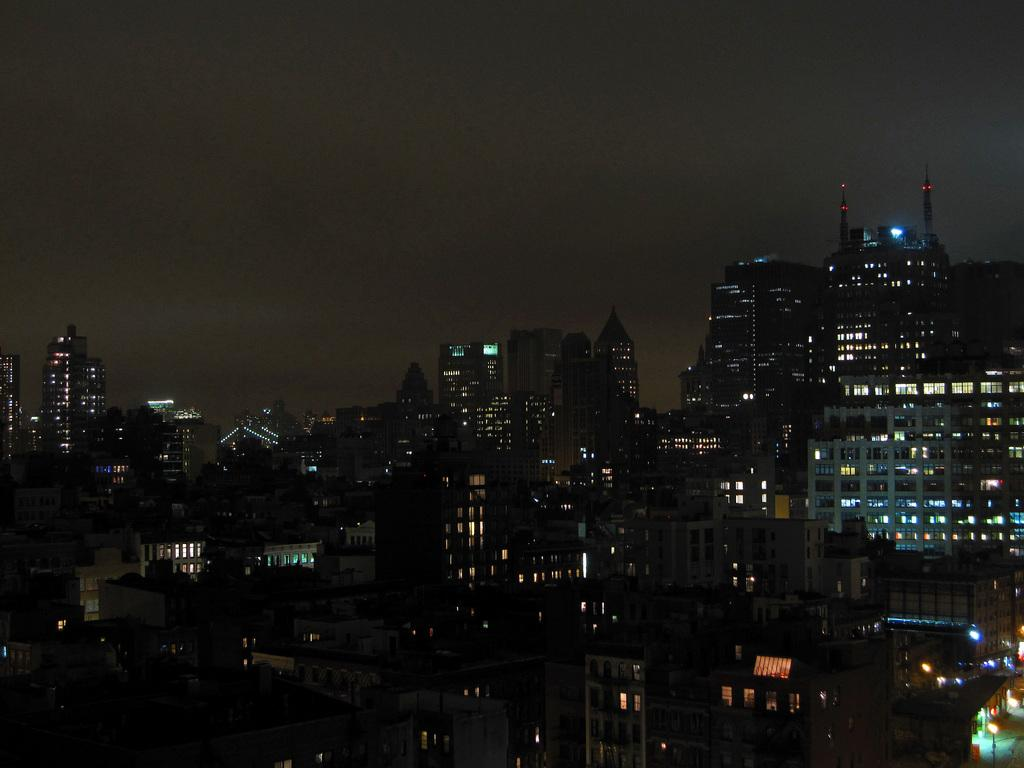What time of day is the image captured? The image is captured at night. What types of structures are visible in the image? There are many houses and buildings in the image. How are the houses and buildings illuminated in the image? The houses and buildings are lightened up with lights. How would you describe the overall appearance of the image? The view is described as beautiful. Can you see a rifle being used by someone in the image? There is no rifle or anyone using a rifle present in the image. What type of expansion is taking place in the image? There is no expansion or any related activity visible in the image. 